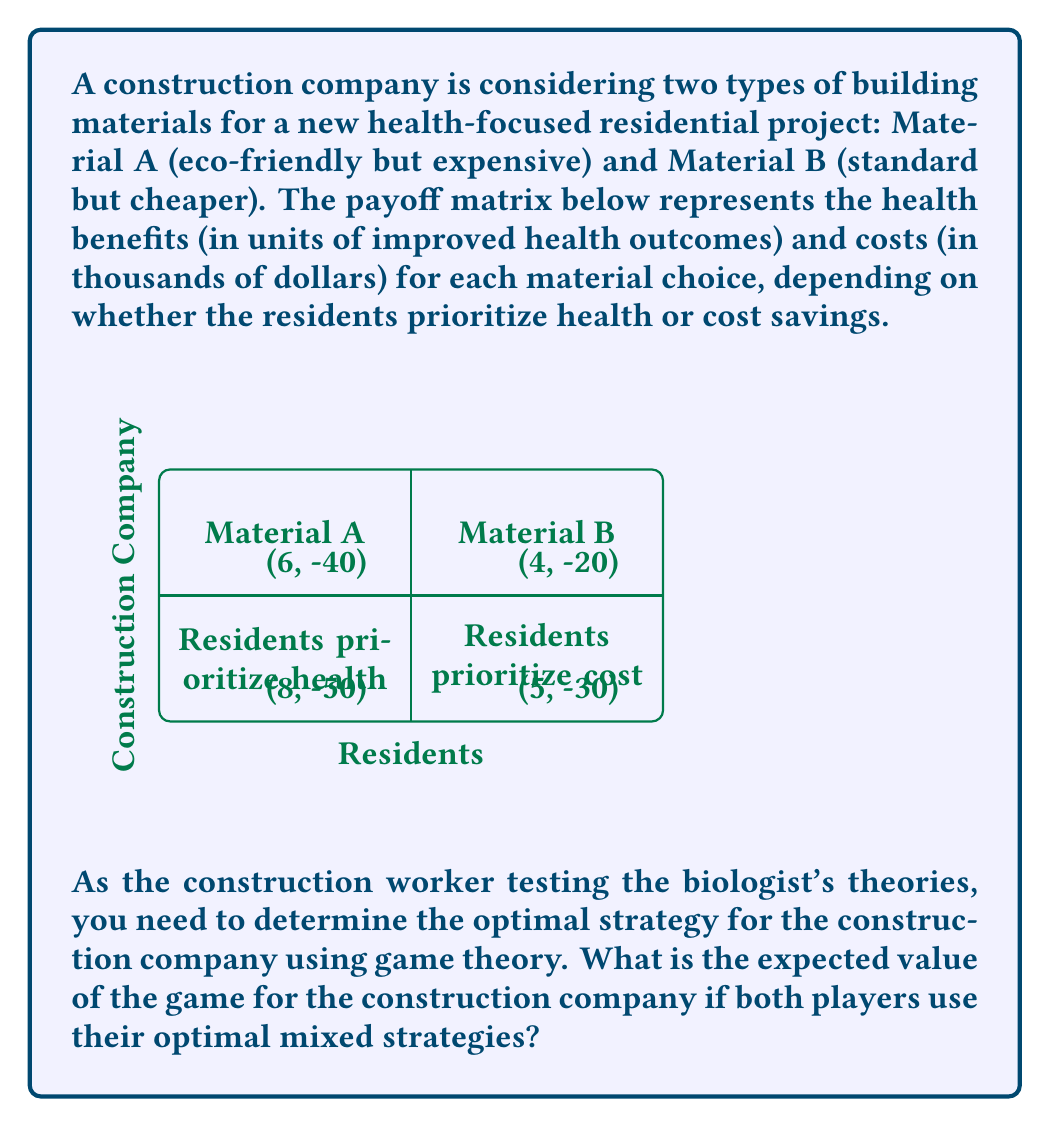Give your solution to this math problem. To solve this problem, we'll follow these steps:

1) First, we need to identify if there's a pure strategy Nash equilibrium.
2) If not, we'll calculate the mixed strategy equilibrium.
3) Finally, we'll determine the expected value for the construction company.

Step 1: Check for pure strategy Nash equilibrium
There's no pure strategy Nash equilibrium because:
- If residents prioritize health, the company prefers Material A (8 > 5)
- If residents prioritize cost, the company prefers Material B (-20 > -40)
- If the company chooses Material A, residents prefer prioritizing health (8 > 6)
- If the company chooses Material B, residents prefer prioritizing cost (-20 > -30)

Step 2: Calculate mixed strategy equilibrium
Let $p$ be the probability of the company choosing Material A, and $q$ be the probability of residents prioritizing health.

For the residents to be indifferent:
$8p + 5(1-p) = 6p + 4(1-p)$
$8p + 5 - 5p = 6p + 4 - 4p$
$3p + 5 = 2p + 4$
$p = 1/3$

For the company to be indifferent:
$8q - 40(1-q) = 5q - 20(1-q)$
$8q - 40 + 40q = 5q - 20 + 20q$
$48q - 40 = 25q - 20$
$23q = 20$
$q = 20/23$

Step 3: Calculate expected value for the construction company
The expected value (EV) is:

$EV = p[8q + 6(1-q)] + (1-p)[5q + 4(1-q)] - [50q + 30(1-q)]p - [40q + 20(1-q)](1-p)$

Substituting the values:

$EV = (1/3)[8(20/23) + 6(3/23)] + (2/3)[5(20/23) + 4(3/23)] - [50(20/23) + 30(3/23)](1/3) - [40(20/23) + 20(3/23)](2/3)$

$EV = (1/3)[160/23 + 18/23] + (2/3)[100/23 + 12/23] - [1000/23 + 90/23](1/3) - [800/23 + 60/23](2/3)$

$EV = (1/3)[178/23] + (2/3)[112/23] - [1090/23](1/3) - [860/23](2/3)$

$EV = 59.33/23 + 74.67/23 - 363.33/23 - 573.33/23$

$EV = -802.66/23 \approx -34.90$
Answer: $-34.90$ (thousand dollars) 